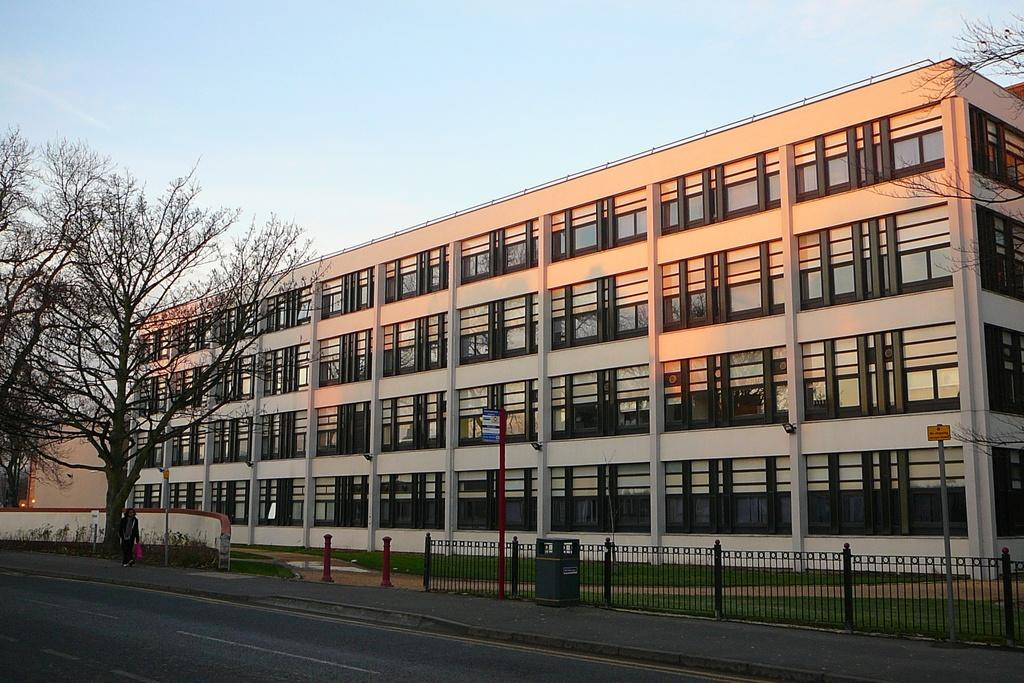What type of structure is depicted in the image? There is a building with many windows in the image. What is located in front of the building? There is a road in front of the building. Can you describe the person in the image? A person is walking on the footpath. What is beside the footpath? There is a tree beside the footpath. What can be seen above the scene? The sky is visible above the scene. What book is the person reading while walking on the footpath? The person in the image is not reading a book; they are simply walking on the footpath. What type of crime is being committed in the image? There is no crime being committed in the image; it depicts a person walking on a footpath near a building and a tree. 